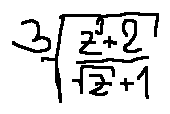<formula> <loc_0><loc_0><loc_500><loc_500>\sqrt { [ } 3 ] { \frac { z ^ { 3 } + 2 } { \sqrt { z } + 1 } }</formula> 